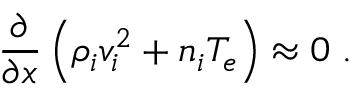Convert formula to latex. <formula><loc_0><loc_0><loc_500><loc_500>\frac { \partial } { \partial x } \left ( \rho _ { i } v _ { i } ^ { 2 } + n _ { i } T _ { e } \right ) \approx 0 \, .</formula> 